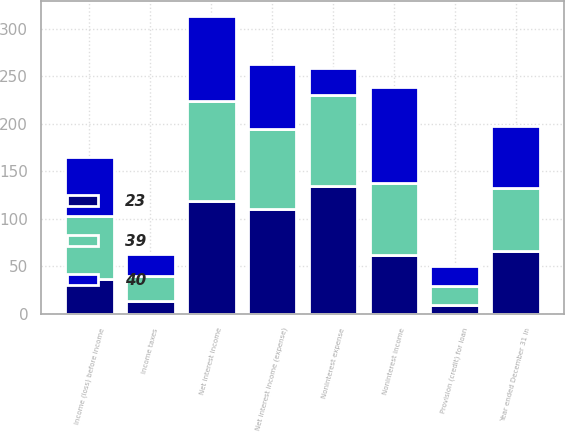<chart> <loc_0><loc_0><loc_500><loc_500><stacked_bar_chart><ecel><fcel>Year ended December 31 in<fcel>Net interest income<fcel>Provision (credit) for loan<fcel>Net interest income (expense)<fcel>Noninterest income<fcel>Noninterest expense<fcel>Income (loss) before income<fcel>Income taxes<nl><fcel>40<fcel>66<fcel>89<fcel>21<fcel>68<fcel>101<fcel>29<fcel>62<fcel>23<nl><fcel>39<fcel>66<fcel>105<fcel>20<fcel>85<fcel>76<fcel>95<fcel>66<fcel>26<nl><fcel>23<fcel>66<fcel>119<fcel>9<fcel>110<fcel>62<fcel>135<fcel>37<fcel>14<nl></chart> 